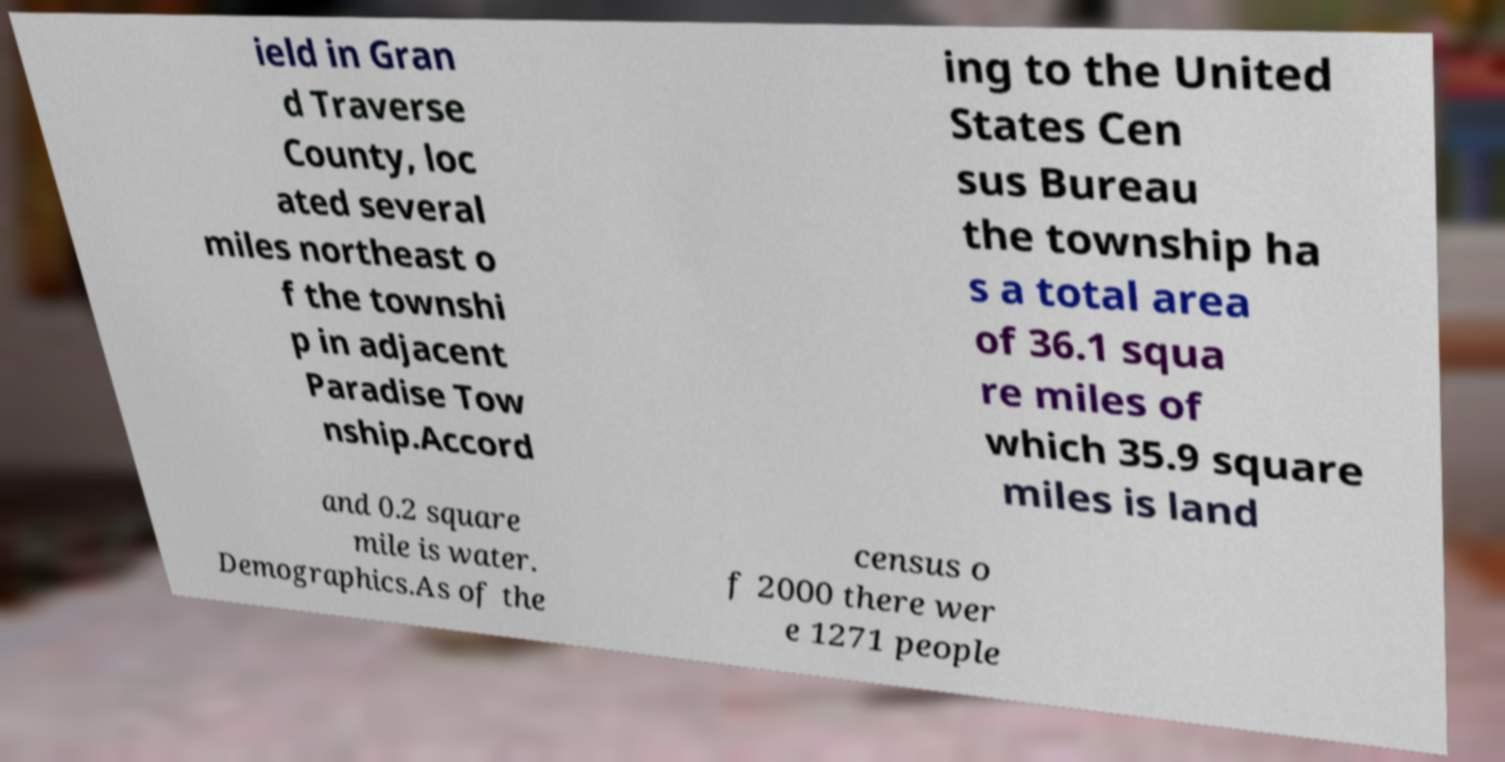Could you extract and type out the text from this image? ield in Gran d Traverse County, loc ated several miles northeast o f the townshi p in adjacent Paradise Tow nship.Accord ing to the United States Cen sus Bureau the township ha s a total area of 36.1 squa re miles of which 35.9 square miles is land and 0.2 square mile is water. Demographics.As of the census o f 2000 there wer e 1271 people 